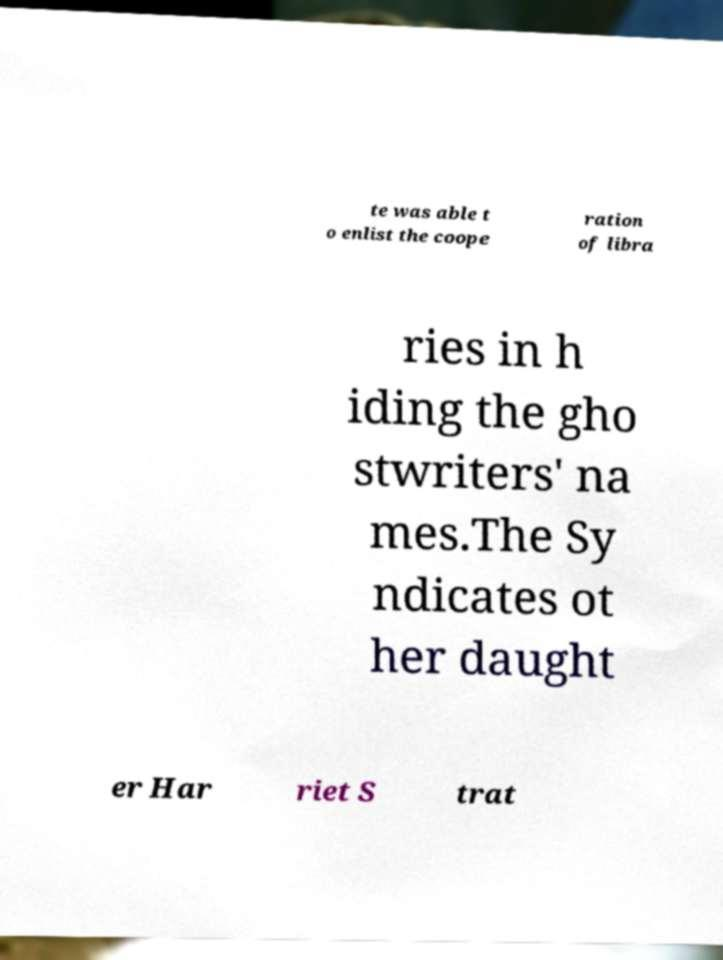Can you read and provide the text displayed in the image?This photo seems to have some interesting text. Can you extract and type it out for me? te was able t o enlist the coope ration of libra ries in h iding the gho stwriters' na mes.The Sy ndicates ot her daught er Har riet S trat 